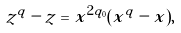Convert formula to latex. <formula><loc_0><loc_0><loc_500><loc_500>z ^ { q } - z & = x ^ { 2 q _ { 0 } } ( x ^ { q } - x ) ,</formula> 